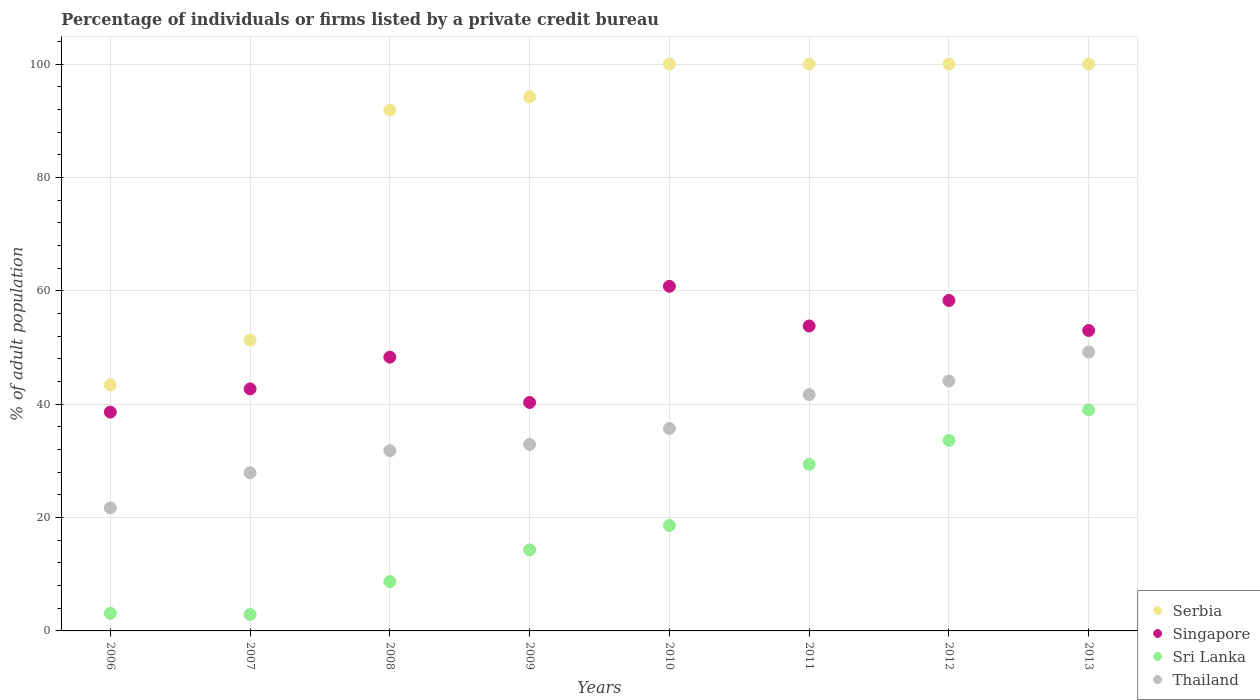Across all years, what is the maximum percentage of population listed by a private credit bureau in Singapore?
Offer a terse response. 60.8. Across all years, what is the minimum percentage of population listed by a private credit bureau in Thailand?
Provide a short and direct response. 21.7. In which year was the percentage of population listed by a private credit bureau in Sri Lanka minimum?
Provide a succinct answer. 2007. What is the total percentage of population listed by a private credit bureau in Singapore in the graph?
Keep it short and to the point. 395.8. What is the difference between the percentage of population listed by a private credit bureau in Singapore in 2007 and that in 2013?
Offer a very short reply. -10.3. What is the difference between the percentage of population listed by a private credit bureau in Thailand in 2011 and the percentage of population listed by a private credit bureau in Sri Lanka in 2013?
Make the answer very short. 2.7. What is the average percentage of population listed by a private credit bureau in Serbia per year?
Your answer should be very brief. 85.1. In the year 2009, what is the difference between the percentage of population listed by a private credit bureau in Serbia and percentage of population listed by a private credit bureau in Sri Lanka?
Offer a very short reply. 79.9. In how many years, is the percentage of population listed by a private credit bureau in Serbia greater than 76 %?
Give a very brief answer. 6. What is the ratio of the percentage of population listed by a private credit bureau in Thailand in 2006 to that in 2008?
Ensure brevity in your answer.  0.68. Is the difference between the percentage of population listed by a private credit bureau in Serbia in 2006 and 2008 greater than the difference between the percentage of population listed by a private credit bureau in Sri Lanka in 2006 and 2008?
Make the answer very short. No. What is the difference between the highest and the second highest percentage of population listed by a private credit bureau in Sri Lanka?
Provide a short and direct response. 5.4. What is the difference between the highest and the lowest percentage of population listed by a private credit bureau in Singapore?
Give a very brief answer. 22.2. In how many years, is the percentage of population listed by a private credit bureau in Serbia greater than the average percentage of population listed by a private credit bureau in Serbia taken over all years?
Offer a terse response. 6. Is the sum of the percentage of population listed by a private credit bureau in Singapore in 2012 and 2013 greater than the maximum percentage of population listed by a private credit bureau in Serbia across all years?
Make the answer very short. Yes. Is it the case that in every year, the sum of the percentage of population listed by a private credit bureau in Singapore and percentage of population listed by a private credit bureau in Sri Lanka  is greater than the sum of percentage of population listed by a private credit bureau in Thailand and percentage of population listed by a private credit bureau in Serbia?
Your answer should be very brief. Yes. Is it the case that in every year, the sum of the percentage of population listed by a private credit bureau in Singapore and percentage of population listed by a private credit bureau in Thailand  is greater than the percentage of population listed by a private credit bureau in Sri Lanka?
Give a very brief answer. Yes. Is the percentage of population listed by a private credit bureau in Singapore strictly greater than the percentage of population listed by a private credit bureau in Serbia over the years?
Your response must be concise. No. How many dotlines are there?
Give a very brief answer. 4. What is the difference between two consecutive major ticks on the Y-axis?
Offer a very short reply. 20. Does the graph contain any zero values?
Ensure brevity in your answer.  No. What is the title of the graph?
Offer a very short reply. Percentage of individuals or firms listed by a private credit bureau. Does "Puerto Rico" appear as one of the legend labels in the graph?
Offer a terse response. No. What is the label or title of the X-axis?
Give a very brief answer. Years. What is the label or title of the Y-axis?
Give a very brief answer. % of adult population. What is the % of adult population of Serbia in 2006?
Ensure brevity in your answer.  43.4. What is the % of adult population of Singapore in 2006?
Provide a short and direct response. 38.6. What is the % of adult population of Sri Lanka in 2006?
Make the answer very short. 3.1. What is the % of adult population of Thailand in 2006?
Ensure brevity in your answer.  21.7. What is the % of adult population of Serbia in 2007?
Your response must be concise. 51.3. What is the % of adult population of Singapore in 2007?
Offer a very short reply. 42.7. What is the % of adult population of Sri Lanka in 2007?
Keep it short and to the point. 2.9. What is the % of adult population in Thailand in 2007?
Your response must be concise. 27.9. What is the % of adult population of Serbia in 2008?
Your answer should be very brief. 91.9. What is the % of adult population in Singapore in 2008?
Your answer should be very brief. 48.3. What is the % of adult population of Sri Lanka in 2008?
Offer a terse response. 8.7. What is the % of adult population of Thailand in 2008?
Give a very brief answer. 31.8. What is the % of adult population in Serbia in 2009?
Ensure brevity in your answer.  94.2. What is the % of adult population of Singapore in 2009?
Give a very brief answer. 40.3. What is the % of adult population of Sri Lanka in 2009?
Provide a short and direct response. 14.3. What is the % of adult population of Thailand in 2009?
Keep it short and to the point. 32.9. What is the % of adult population of Singapore in 2010?
Your answer should be very brief. 60.8. What is the % of adult population of Thailand in 2010?
Give a very brief answer. 35.7. What is the % of adult population of Serbia in 2011?
Offer a terse response. 100. What is the % of adult population in Singapore in 2011?
Keep it short and to the point. 53.8. What is the % of adult population in Sri Lanka in 2011?
Provide a succinct answer. 29.4. What is the % of adult population of Thailand in 2011?
Give a very brief answer. 41.7. What is the % of adult population in Singapore in 2012?
Make the answer very short. 58.3. What is the % of adult population of Sri Lanka in 2012?
Your answer should be very brief. 33.6. What is the % of adult population in Thailand in 2012?
Offer a terse response. 44.1. What is the % of adult population in Singapore in 2013?
Keep it short and to the point. 53. What is the % of adult population of Thailand in 2013?
Ensure brevity in your answer.  49.2. Across all years, what is the maximum % of adult population in Serbia?
Your answer should be very brief. 100. Across all years, what is the maximum % of adult population of Singapore?
Provide a short and direct response. 60.8. Across all years, what is the maximum % of adult population in Thailand?
Make the answer very short. 49.2. Across all years, what is the minimum % of adult population in Serbia?
Your response must be concise. 43.4. Across all years, what is the minimum % of adult population of Singapore?
Give a very brief answer. 38.6. Across all years, what is the minimum % of adult population in Thailand?
Provide a succinct answer. 21.7. What is the total % of adult population in Serbia in the graph?
Your response must be concise. 680.8. What is the total % of adult population of Singapore in the graph?
Your response must be concise. 395.8. What is the total % of adult population in Sri Lanka in the graph?
Your response must be concise. 149.6. What is the total % of adult population of Thailand in the graph?
Make the answer very short. 285. What is the difference between the % of adult population of Thailand in 2006 and that in 2007?
Make the answer very short. -6.2. What is the difference between the % of adult population of Serbia in 2006 and that in 2008?
Keep it short and to the point. -48.5. What is the difference between the % of adult population of Serbia in 2006 and that in 2009?
Make the answer very short. -50.8. What is the difference between the % of adult population in Thailand in 2006 and that in 2009?
Offer a terse response. -11.2. What is the difference between the % of adult population of Serbia in 2006 and that in 2010?
Your answer should be compact. -56.6. What is the difference between the % of adult population in Singapore in 2006 and that in 2010?
Your response must be concise. -22.2. What is the difference between the % of adult population in Sri Lanka in 2006 and that in 2010?
Offer a terse response. -15.5. What is the difference between the % of adult population of Thailand in 2006 and that in 2010?
Your answer should be compact. -14. What is the difference between the % of adult population in Serbia in 2006 and that in 2011?
Make the answer very short. -56.6. What is the difference between the % of adult population in Singapore in 2006 and that in 2011?
Provide a short and direct response. -15.2. What is the difference between the % of adult population of Sri Lanka in 2006 and that in 2011?
Your answer should be compact. -26.3. What is the difference between the % of adult population of Thailand in 2006 and that in 2011?
Make the answer very short. -20. What is the difference between the % of adult population of Serbia in 2006 and that in 2012?
Your answer should be very brief. -56.6. What is the difference between the % of adult population of Singapore in 2006 and that in 2012?
Your response must be concise. -19.7. What is the difference between the % of adult population of Sri Lanka in 2006 and that in 2012?
Provide a succinct answer. -30.5. What is the difference between the % of adult population in Thailand in 2006 and that in 2012?
Give a very brief answer. -22.4. What is the difference between the % of adult population in Serbia in 2006 and that in 2013?
Offer a very short reply. -56.6. What is the difference between the % of adult population in Singapore in 2006 and that in 2013?
Make the answer very short. -14.4. What is the difference between the % of adult population in Sri Lanka in 2006 and that in 2013?
Provide a short and direct response. -35.9. What is the difference between the % of adult population in Thailand in 2006 and that in 2013?
Keep it short and to the point. -27.5. What is the difference between the % of adult population in Serbia in 2007 and that in 2008?
Give a very brief answer. -40.6. What is the difference between the % of adult population of Singapore in 2007 and that in 2008?
Provide a succinct answer. -5.6. What is the difference between the % of adult population in Sri Lanka in 2007 and that in 2008?
Give a very brief answer. -5.8. What is the difference between the % of adult population in Serbia in 2007 and that in 2009?
Make the answer very short. -42.9. What is the difference between the % of adult population in Sri Lanka in 2007 and that in 2009?
Give a very brief answer. -11.4. What is the difference between the % of adult population in Serbia in 2007 and that in 2010?
Your response must be concise. -48.7. What is the difference between the % of adult population in Singapore in 2007 and that in 2010?
Keep it short and to the point. -18.1. What is the difference between the % of adult population of Sri Lanka in 2007 and that in 2010?
Your answer should be compact. -15.7. What is the difference between the % of adult population of Serbia in 2007 and that in 2011?
Provide a short and direct response. -48.7. What is the difference between the % of adult population in Sri Lanka in 2007 and that in 2011?
Provide a succinct answer. -26.5. What is the difference between the % of adult population in Serbia in 2007 and that in 2012?
Offer a very short reply. -48.7. What is the difference between the % of adult population of Singapore in 2007 and that in 2012?
Your answer should be compact. -15.6. What is the difference between the % of adult population of Sri Lanka in 2007 and that in 2012?
Your response must be concise. -30.7. What is the difference between the % of adult population of Thailand in 2007 and that in 2012?
Keep it short and to the point. -16.2. What is the difference between the % of adult population of Serbia in 2007 and that in 2013?
Offer a terse response. -48.7. What is the difference between the % of adult population in Singapore in 2007 and that in 2013?
Ensure brevity in your answer.  -10.3. What is the difference between the % of adult population in Sri Lanka in 2007 and that in 2013?
Give a very brief answer. -36.1. What is the difference between the % of adult population in Thailand in 2007 and that in 2013?
Ensure brevity in your answer.  -21.3. What is the difference between the % of adult population in Singapore in 2008 and that in 2009?
Ensure brevity in your answer.  8. What is the difference between the % of adult population in Sri Lanka in 2008 and that in 2009?
Your answer should be compact. -5.6. What is the difference between the % of adult population in Sri Lanka in 2008 and that in 2010?
Provide a short and direct response. -9.9. What is the difference between the % of adult population in Serbia in 2008 and that in 2011?
Give a very brief answer. -8.1. What is the difference between the % of adult population in Singapore in 2008 and that in 2011?
Offer a very short reply. -5.5. What is the difference between the % of adult population in Sri Lanka in 2008 and that in 2011?
Your response must be concise. -20.7. What is the difference between the % of adult population of Serbia in 2008 and that in 2012?
Your answer should be compact. -8.1. What is the difference between the % of adult population of Sri Lanka in 2008 and that in 2012?
Offer a very short reply. -24.9. What is the difference between the % of adult population in Thailand in 2008 and that in 2012?
Your response must be concise. -12.3. What is the difference between the % of adult population of Sri Lanka in 2008 and that in 2013?
Provide a succinct answer. -30.3. What is the difference between the % of adult population of Thailand in 2008 and that in 2013?
Your answer should be compact. -17.4. What is the difference between the % of adult population of Serbia in 2009 and that in 2010?
Keep it short and to the point. -5.8. What is the difference between the % of adult population in Singapore in 2009 and that in 2010?
Ensure brevity in your answer.  -20.5. What is the difference between the % of adult population in Thailand in 2009 and that in 2010?
Your answer should be very brief. -2.8. What is the difference between the % of adult population of Sri Lanka in 2009 and that in 2011?
Your answer should be very brief. -15.1. What is the difference between the % of adult population of Serbia in 2009 and that in 2012?
Your response must be concise. -5.8. What is the difference between the % of adult population in Sri Lanka in 2009 and that in 2012?
Give a very brief answer. -19.3. What is the difference between the % of adult population in Serbia in 2009 and that in 2013?
Ensure brevity in your answer.  -5.8. What is the difference between the % of adult population in Sri Lanka in 2009 and that in 2013?
Ensure brevity in your answer.  -24.7. What is the difference between the % of adult population of Thailand in 2009 and that in 2013?
Ensure brevity in your answer.  -16.3. What is the difference between the % of adult population in Singapore in 2010 and that in 2011?
Your response must be concise. 7. What is the difference between the % of adult population of Serbia in 2010 and that in 2012?
Your answer should be very brief. 0. What is the difference between the % of adult population of Thailand in 2010 and that in 2012?
Your answer should be very brief. -8.4. What is the difference between the % of adult population in Singapore in 2010 and that in 2013?
Ensure brevity in your answer.  7.8. What is the difference between the % of adult population in Sri Lanka in 2010 and that in 2013?
Your answer should be compact. -20.4. What is the difference between the % of adult population in Thailand in 2010 and that in 2013?
Provide a short and direct response. -13.5. What is the difference between the % of adult population in Sri Lanka in 2011 and that in 2012?
Offer a very short reply. -4.2. What is the difference between the % of adult population of Sri Lanka in 2011 and that in 2013?
Ensure brevity in your answer.  -9.6. What is the difference between the % of adult population of Serbia in 2012 and that in 2013?
Your response must be concise. 0. What is the difference between the % of adult population of Singapore in 2012 and that in 2013?
Ensure brevity in your answer.  5.3. What is the difference between the % of adult population in Serbia in 2006 and the % of adult population in Singapore in 2007?
Ensure brevity in your answer.  0.7. What is the difference between the % of adult population in Serbia in 2006 and the % of adult population in Sri Lanka in 2007?
Ensure brevity in your answer.  40.5. What is the difference between the % of adult population in Serbia in 2006 and the % of adult population in Thailand in 2007?
Keep it short and to the point. 15.5. What is the difference between the % of adult population of Singapore in 2006 and the % of adult population of Sri Lanka in 2007?
Offer a terse response. 35.7. What is the difference between the % of adult population of Sri Lanka in 2006 and the % of adult population of Thailand in 2007?
Your answer should be very brief. -24.8. What is the difference between the % of adult population in Serbia in 2006 and the % of adult population in Singapore in 2008?
Provide a short and direct response. -4.9. What is the difference between the % of adult population of Serbia in 2006 and the % of adult population of Sri Lanka in 2008?
Keep it short and to the point. 34.7. What is the difference between the % of adult population in Singapore in 2006 and the % of adult population in Sri Lanka in 2008?
Ensure brevity in your answer.  29.9. What is the difference between the % of adult population of Sri Lanka in 2006 and the % of adult population of Thailand in 2008?
Provide a short and direct response. -28.7. What is the difference between the % of adult population in Serbia in 2006 and the % of adult population in Sri Lanka in 2009?
Your response must be concise. 29.1. What is the difference between the % of adult population in Serbia in 2006 and the % of adult population in Thailand in 2009?
Offer a very short reply. 10.5. What is the difference between the % of adult population of Singapore in 2006 and the % of adult population of Sri Lanka in 2009?
Give a very brief answer. 24.3. What is the difference between the % of adult population in Singapore in 2006 and the % of adult population in Thailand in 2009?
Your response must be concise. 5.7. What is the difference between the % of adult population of Sri Lanka in 2006 and the % of adult population of Thailand in 2009?
Your answer should be very brief. -29.8. What is the difference between the % of adult population in Serbia in 2006 and the % of adult population in Singapore in 2010?
Offer a terse response. -17.4. What is the difference between the % of adult population in Serbia in 2006 and the % of adult population in Sri Lanka in 2010?
Your response must be concise. 24.8. What is the difference between the % of adult population of Singapore in 2006 and the % of adult population of Thailand in 2010?
Give a very brief answer. 2.9. What is the difference between the % of adult population of Sri Lanka in 2006 and the % of adult population of Thailand in 2010?
Make the answer very short. -32.6. What is the difference between the % of adult population in Serbia in 2006 and the % of adult population in Sri Lanka in 2011?
Make the answer very short. 14. What is the difference between the % of adult population of Sri Lanka in 2006 and the % of adult population of Thailand in 2011?
Make the answer very short. -38.6. What is the difference between the % of adult population in Serbia in 2006 and the % of adult population in Singapore in 2012?
Provide a succinct answer. -14.9. What is the difference between the % of adult population in Serbia in 2006 and the % of adult population in Thailand in 2012?
Your response must be concise. -0.7. What is the difference between the % of adult population of Sri Lanka in 2006 and the % of adult population of Thailand in 2012?
Keep it short and to the point. -41. What is the difference between the % of adult population in Serbia in 2006 and the % of adult population in Singapore in 2013?
Your response must be concise. -9.6. What is the difference between the % of adult population of Serbia in 2006 and the % of adult population of Sri Lanka in 2013?
Offer a very short reply. 4.4. What is the difference between the % of adult population of Singapore in 2006 and the % of adult population of Sri Lanka in 2013?
Your response must be concise. -0.4. What is the difference between the % of adult population in Singapore in 2006 and the % of adult population in Thailand in 2013?
Ensure brevity in your answer.  -10.6. What is the difference between the % of adult population in Sri Lanka in 2006 and the % of adult population in Thailand in 2013?
Your answer should be very brief. -46.1. What is the difference between the % of adult population of Serbia in 2007 and the % of adult population of Singapore in 2008?
Offer a very short reply. 3. What is the difference between the % of adult population in Serbia in 2007 and the % of adult population in Sri Lanka in 2008?
Offer a very short reply. 42.6. What is the difference between the % of adult population of Serbia in 2007 and the % of adult population of Thailand in 2008?
Keep it short and to the point. 19.5. What is the difference between the % of adult population in Sri Lanka in 2007 and the % of adult population in Thailand in 2008?
Your answer should be compact. -28.9. What is the difference between the % of adult population of Singapore in 2007 and the % of adult population of Sri Lanka in 2009?
Your answer should be very brief. 28.4. What is the difference between the % of adult population of Serbia in 2007 and the % of adult population of Sri Lanka in 2010?
Your answer should be very brief. 32.7. What is the difference between the % of adult population of Serbia in 2007 and the % of adult population of Thailand in 2010?
Offer a very short reply. 15.6. What is the difference between the % of adult population of Singapore in 2007 and the % of adult population of Sri Lanka in 2010?
Your response must be concise. 24.1. What is the difference between the % of adult population in Singapore in 2007 and the % of adult population in Thailand in 2010?
Keep it short and to the point. 7. What is the difference between the % of adult population in Sri Lanka in 2007 and the % of adult population in Thailand in 2010?
Your answer should be compact. -32.8. What is the difference between the % of adult population of Serbia in 2007 and the % of adult population of Sri Lanka in 2011?
Your answer should be very brief. 21.9. What is the difference between the % of adult population of Serbia in 2007 and the % of adult population of Thailand in 2011?
Your response must be concise. 9.6. What is the difference between the % of adult population of Singapore in 2007 and the % of adult population of Thailand in 2011?
Your answer should be very brief. 1. What is the difference between the % of adult population of Sri Lanka in 2007 and the % of adult population of Thailand in 2011?
Offer a very short reply. -38.8. What is the difference between the % of adult population of Sri Lanka in 2007 and the % of adult population of Thailand in 2012?
Give a very brief answer. -41.2. What is the difference between the % of adult population of Serbia in 2007 and the % of adult population of Thailand in 2013?
Keep it short and to the point. 2.1. What is the difference between the % of adult population of Sri Lanka in 2007 and the % of adult population of Thailand in 2013?
Provide a succinct answer. -46.3. What is the difference between the % of adult population of Serbia in 2008 and the % of adult population of Singapore in 2009?
Your response must be concise. 51.6. What is the difference between the % of adult population of Serbia in 2008 and the % of adult population of Sri Lanka in 2009?
Make the answer very short. 77.6. What is the difference between the % of adult population of Singapore in 2008 and the % of adult population of Sri Lanka in 2009?
Give a very brief answer. 34. What is the difference between the % of adult population of Sri Lanka in 2008 and the % of adult population of Thailand in 2009?
Keep it short and to the point. -24.2. What is the difference between the % of adult population in Serbia in 2008 and the % of adult population in Singapore in 2010?
Keep it short and to the point. 31.1. What is the difference between the % of adult population in Serbia in 2008 and the % of adult population in Sri Lanka in 2010?
Offer a very short reply. 73.3. What is the difference between the % of adult population in Serbia in 2008 and the % of adult population in Thailand in 2010?
Offer a terse response. 56.2. What is the difference between the % of adult population in Singapore in 2008 and the % of adult population in Sri Lanka in 2010?
Make the answer very short. 29.7. What is the difference between the % of adult population of Sri Lanka in 2008 and the % of adult population of Thailand in 2010?
Ensure brevity in your answer.  -27. What is the difference between the % of adult population in Serbia in 2008 and the % of adult population in Singapore in 2011?
Make the answer very short. 38.1. What is the difference between the % of adult population of Serbia in 2008 and the % of adult population of Sri Lanka in 2011?
Offer a terse response. 62.5. What is the difference between the % of adult population in Serbia in 2008 and the % of adult population in Thailand in 2011?
Your response must be concise. 50.2. What is the difference between the % of adult population of Singapore in 2008 and the % of adult population of Thailand in 2011?
Keep it short and to the point. 6.6. What is the difference between the % of adult population of Sri Lanka in 2008 and the % of adult population of Thailand in 2011?
Your answer should be compact. -33. What is the difference between the % of adult population in Serbia in 2008 and the % of adult population in Singapore in 2012?
Your answer should be very brief. 33.6. What is the difference between the % of adult population in Serbia in 2008 and the % of adult population in Sri Lanka in 2012?
Make the answer very short. 58.3. What is the difference between the % of adult population in Serbia in 2008 and the % of adult population in Thailand in 2012?
Your answer should be very brief. 47.8. What is the difference between the % of adult population in Singapore in 2008 and the % of adult population in Sri Lanka in 2012?
Provide a short and direct response. 14.7. What is the difference between the % of adult population of Singapore in 2008 and the % of adult population of Thailand in 2012?
Your response must be concise. 4.2. What is the difference between the % of adult population in Sri Lanka in 2008 and the % of adult population in Thailand in 2012?
Your response must be concise. -35.4. What is the difference between the % of adult population in Serbia in 2008 and the % of adult population in Singapore in 2013?
Provide a short and direct response. 38.9. What is the difference between the % of adult population in Serbia in 2008 and the % of adult population in Sri Lanka in 2013?
Provide a short and direct response. 52.9. What is the difference between the % of adult population in Serbia in 2008 and the % of adult population in Thailand in 2013?
Make the answer very short. 42.7. What is the difference between the % of adult population in Singapore in 2008 and the % of adult population in Thailand in 2013?
Provide a succinct answer. -0.9. What is the difference between the % of adult population in Sri Lanka in 2008 and the % of adult population in Thailand in 2013?
Your answer should be compact. -40.5. What is the difference between the % of adult population of Serbia in 2009 and the % of adult population of Singapore in 2010?
Make the answer very short. 33.4. What is the difference between the % of adult population in Serbia in 2009 and the % of adult population in Sri Lanka in 2010?
Offer a very short reply. 75.6. What is the difference between the % of adult population of Serbia in 2009 and the % of adult population of Thailand in 2010?
Provide a succinct answer. 58.5. What is the difference between the % of adult population of Singapore in 2009 and the % of adult population of Sri Lanka in 2010?
Offer a very short reply. 21.7. What is the difference between the % of adult population of Singapore in 2009 and the % of adult population of Thailand in 2010?
Offer a very short reply. 4.6. What is the difference between the % of adult population of Sri Lanka in 2009 and the % of adult population of Thailand in 2010?
Offer a very short reply. -21.4. What is the difference between the % of adult population of Serbia in 2009 and the % of adult population of Singapore in 2011?
Make the answer very short. 40.4. What is the difference between the % of adult population of Serbia in 2009 and the % of adult population of Sri Lanka in 2011?
Make the answer very short. 64.8. What is the difference between the % of adult population in Serbia in 2009 and the % of adult population in Thailand in 2011?
Make the answer very short. 52.5. What is the difference between the % of adult population in Singapore in 2009 and the % of adult population in Sri Lanka in 2011?
Your answer should be compact. 10.9. What is the difference between the % of adult population in Singapore in 2009 and the % of adult population in Thailand in 2011?
Your response must be concise. -1.4. What is the difference between the % of adult population in Sri Lanka in 2009 and the % of adult population in Thailand in 2011?
Offer a very short reply. -27.4. What is the difference between the % of adult population in Serbia in 2009 and the % of adult population in Singapore in 2012?
Provide a succinct answer. 35.9. What is the difference between the % of adult population in Serbia in 2009 and the % of adult population in Sri Lanka in 2012?
Ensure brevity in your answer.  60.6. What is the difference between the % of adult population in Serbia in 2009 and the % of adult population in Thailand in 2012?
Provide a succinct answer. 50.1. What is the difference between the % of adult population of Singapore in 2009 and the % of adult population of Sri Lanka in 2012?
Offer a terse response. 6.7. What is the difference between the % of adult population of Sri Lanka in 2009 and the % of adult population of Thailand in 2012?
Offer a very short reply. -29.8. What is the difference between the % of adult population in Serbia in 2009 and the % of adult population in Singapore in 2013?
Make the answer very short. 41.2. What is the difference between the % of adult population of Serbia in 2009 and the % of adult population of Sri Lanka in 2013?
Offer a very short reply. 55.2. What is the difference between the % of adult population of Sri Lanka in 2009 and the % of adult population of Thailand in 2013?
Your response must be concise. -34.9. What is the difference between the % of adult population of Serbia in 2010 and the % of adult population of Singapore in 2011?
Offer a very short reply. 46.2. What is the difference between the % of adult population of Serbia in 2010 and the % of adult population of Sri Lanka in 2011?
Provide a short and direct response. 70.6. What is the difference between the % of adult population in Serbia in 2010 and the % of adult population in Thailand in 2011?
Provide a succinct answer. 58.3. What is the difference between the % of adult population of Singapore in 2010 and the % of adult population of Sri Lanka in 2011?
Ensure brevity in your answer.  31.4. What is the difference between the % of adult population of Singapore in 2010 and the % of adult population of Thailand in 2011?
Keep it short and to the point. 19.1. What is the difference between the % of adult population in Sri Lanka in 2010 and the % of adult population in Thailand in 2011?
Your answer should be very brief. -23.1. What is the difference between the % of adult population in Serbia in 2010 and the % of adult population in Singapore in 2012?
Keep it short and to the point. 41.7. What is the difference between the % of adult population in Serbia in 2010 and the % of adult population in Sri Lanka in 2012?
Provide a succinct answer. 66.4. What is the difference between the % of adult population of Serbia in 2010 and the % of adult population of Thailand in 2012?
Provide a short and direct response. 55.9. What is the difference between the % of adult population in Singapore in 2010 and the % of adult population in Sri Lanka in 2012?
Offer a terse response. 27.2. What is the difference between the % of adult population in Singapore in 2010 and the % of adult population in Thailand in 2012?
Your response must be concise. 16.7. What is the difference between the % of adult population in Sri Lanka in 2010 and the % of adult population in Thailand in 2012?
Keep it short and to the point. -25.5. What is the difference between the % of adult population of Serbia in 2010 and the % of adult population of Singapore in 2013?
Provide a short and direct response. 47. What is the difference between the % of adult population of Serbia in 2010 and the % of adult population of Thailand in 2013?
Your response must be concise. 50.8. What is the difference between the % of adult population of Singapore in 2010 and the % of adult population of Sri Lanka in 2013?
Offer a very short reply. 21.8. What is the difference between the % of adult population of Singapore in 2010 and the % of adult population of Thailand in 2013?
Offer a very short reply. 11.6. What is the difference between the % of adult population of Sri Lanka in 2010 and the % of adult population of Thailand in 2013?
Keep it short and to the point. -30.6. What is the difference between the % of adult population of Serbia in 2011 and the % of adult population of Singapore in 2012?
Ensure brevity in your answer.  41.7. What is the difference between the % of adult population of Serbia in 2011 and the % of adult population of Sri Lanka in 2012?
Offer a very short reply. 66.4. What is the difference between the % of adult population of Serbia in 2011 and the % of adult population of Thailand in 2012?
Ensure brevity in your answer.  55.9. What is the difference between the % of adult population of Singapore in 2011 and the % of adult population of Sri Lanka in 2012?
Your answer should be compact. 20.2. What is the difference between the % of adult population of Singapore in 2011 and the % of adult population of Thailand in 2012?
Provide a succinct answer. 9.7. What is the difference between the % of adult population in Sri Lanka in 2011 and the % of adult population in Thailand in 2012?
Your answer should be very brief. -14.7. What is the difference between the % of adult population of Serbia in 2011 and the % of adult population of Singapore in 2013?
Keep it short and to the point. 47. What is the difference between the % of adult population in Serbia in 2011 and the % of adult population in Thailand in 2013?
Offer a very short reply. 50.8. What is the difference between the % of adult population of Singapore in 2011 and the % of adult population of Sri Lanka in 2013?
Offer a terse response. 14.8. What is the difference between the % of adult population of Sri Lanka in 2011 and the % of adult population of Thailand in 2013?
Provide a short and direct response. -19.8. What is the difference between the % of adult population in Serbia in 2012 and the % of adult population in Sri Lanka in 2013?
Keep it short and to the point. 61. What is the difference between the % of adult population of Serbia in 2012 and the % of adult population of Thailand in 2013?
Offer a very short reply. 50.8. What is the difference between the % of adult population in Singapore in 2012 and the % of adult population in Sri Lanka in 2013?
Your answer should be very brief. 19.3. What is the difference between the % of adult population in Singapore in 2012 and the % of adult population in Thailand in 2013?
Your answer should be very brief. 9.1. What is the difference between the % of adult population of Sri Lanka in 2012 and the % of adult population of Thailand in 2013?
Provide a succinct answer. -15.6. What is the average % of adult population of Serbia per year?
Give a very brief answer. 85.1. What is the average % of adult population of Singapore per year?
Provide a succinct answer. 49.48. What is the average % of adult population in Thailand per year?
Your answer should be very brief. 35.62. In the year 2006, what is the difference between the % of adult population in Serbia and % of adult population in Singapore?
Provide a short and direct response. 4.8. In the year 2006, what is the difference between the % of adult population in Serbia and % of adult population in Sri Lanka?
Your answer should be very brief. 40.3. In the year 2006, what is the difference between the % of adult population in Serbia and % of adult population in Thailand?
Ensure brevity in your answer.  21.7. In the year 2006, what is the difference between the % of adult population in Singapore and % of adult population in Sri Lanka?
Offer a very short reply. 35.5. In the year 2006, what is the difference between the % of adult population in Sri Lanka and % of adult population in Thailand?
Your response must be concise. -18.6. In the year 2007, what is the difference between the % of adult population in Serbia and % of adult population in Singapore?
Your answer should be very brief. 8.6. In the year 2007, what is the difference between the % of adult population of Serbia and % of adult population of Sri Lanka?
Your answer should be very brief. 48.4. In the year 2007, what is the difference between the % of adult population in Serbia and % of adult population in Thailand?
Keep it short and to the point. 23.4. In the year 2007, what is the difference between the % of adult population of Singapore and % of adult population of Sri Lanka?
Your response must be concise. 39.8. In the year 2007, what is the difference between the % of adult population in Singapore and % of adult population in Thailand?
Give a very brief answer. 14.8. In the year 2007, what is the difference between the % of adult population in Sri Lanka and % of adult population in Thailand?
Make the answer very short. -25. In the year 2008, what is the difference between the % of adult population of Serbia and % of adult population of Singapore?
Offer a very short reply. 43.6. In the year 2008, what is the difference between the % of adult population in Serbia and % of adult population in Sri Lanka?
Keep it short and to the point. 83.2. In the year 2008, what is the difference between the % of adult population of Serbia and % of adult population of Thailand?
Your response must be concise. 60.1. In the year 2008, what is the difference between the % of adult population of Singapore and % of adult population of Sri Lanka?
Your answer should be compact. 39.6. In the year 2008, what is the difference between the % of adult population in Singapore and % of adult population in Thailand?
Provide a short and direct response. 16.5. In the year 2008, what is the difference between the % of adult population in Sri Lanka and % of adult population in Thailand?
Offer a terse response. -23.1. In the year 2009, what is the difference between the % of adult population of Serbia and % of adult population of Singapore?
Provide a succinct answer. 53.9. In the year 2009, what is the difference between the % of adult population in Serbia and % of adult population in Sri Lanka?
Your answer should be compact. 79.9. In the year 2009, what is the difference between the % of adult population of Serbia and % of adult population of Thailand?
Provide a succinct answer. 61.3. In the year 2009, what is the difference between the % of adult population of Singapore and % of adult population of Sri Lanka?
Ensure brevity in your answer.  26. In the year 2009, what is the difference between the % of adult population in Sri Lanka and % of adult population in Thailand?
Offer a very short reply. -18.6. In the year 2010, what is the difference between the % of adult population of Serbia and % of adult population of Singapore?
Your answer should be compact. 39.2. In the year 2010, what is the difference between the % of adult population of Serbia and % of adult population of Sri Lanka?
Provide a short and direct response. 81.4. In the year 2010, what is the difference between the % of adult population in Serbia and % of adult population in Thailand?
Offer a terse response. 64.3. In the year 2010, what is the difference between the % of adult population in Singapore and % of adult population in Sri Lanka?
Ensure brevity in your answer.  42.2. In the year 2010, what is the difference between the % of adult population in Singapore and % of adult population in Thailand?
Ensure brevity in your answer.  25.1. In the year 2010, what is the difference between the % of adult population in Sri Lanka and % of adult population in Thailand?
Offer a very short reply. -17.1. In the year 2011, what is the difference between the % of adult population of Serbia and % of adult population of Singapore?
Give a very brief answer. 46.2. In the year 2011, what is the difference between the % of adult population in Serbia and % of adult population in Sri Lanka?
Your answer should be very brief. 70.6. In the year 2011, what is the difference between the % of adult population in Serbia and % of adult population in Thailand?
Give a very brief answer. 58.3. In the year 2011, what is the difference between the % of adult population in Singapore and % of adult population in Sri Lanka?
Provide a succinct answer. 24.4. In the year 2012, what is the difference between the % of adult population of Serbia and % of adult population of Singapore?
Give a very brief answer. 41.7. In the year 2012, what is the difference between the % of adult population in Serbia and % of adult population in Sri Lanka?
Provide a short and direct response. 66.4. In the year 2012, what is the difference between the % of adult population in Serbia and % of adult population in Thailand?
Offer a very short reply. 55.9. In the year 2012, what is the difference between the % of adult population in Singapore and % of adult population in Sri Lanka?
Your answer should be compact. 24.7. In the year 2012, what is the difference between the % of adult population of Singapore and % of adult population of Thailand?
Your answer should be compact. 14.2. In the year 2012, what is the difference between the % of adult population of Sri Lanka and % of adult population of Thailand?
Ensure brevity in your answer.  -10.5. In the year 2013, what is the difference between the % of adult population of Serbia and % of adult population of Singapore?
Keep it short and to the point. 47. In the year 2013, what is the difference between the % of adult population in Serbia and % of adult population in Sri Lanka?
Your answer should be very brief. 61. In the year 2013, what is the difference between the % of adult population in Serbia and % of adult population in Thailand?
Make the answer very short. 50.8. In the year 2013, what is the difference between the % of adult population in Singapore and % of adult population in Thailand?
Provide a succinct answer. 3.8. In the year 2013, what is the difference between the % of adult population of Sri Lanka and % of adult population of Thailand?
Your answer should be compact. -10.2. What is the ratio of the % of adult population in Serbia in 2006 to that in 2007?
Offer a terse response. 0.85. What is the ratio of the % of adult population in Singapore in 2006 to that in 2007?
Provide a short and direct response. 0.9. What is the ratio of the % of adult population in Sri Lanka in 2006 to that in 2007?
Offer a terse response. 1.07. What is the ratio of the % of adult population of Thailand in 2006 to that in 2007?
Offer a terse response. 0.78. What is the ratio of the % of adult population in Serbia in 2006 to that in 2008?
Your response must be concise. 0.47. What is the ratio of the % of adult population of Singapore in 2006 to that in 2008?
Make the answer very short. 0.8. What is the ratio of the % of adult population of Sri Lanka in 2006 to that in 2008?
Your answer should be compact. 0.36. What is the ratio of the % of adult population of Thailand in 2006 to that in 2008?
Your answer should be very brief. 0.68. What is the ratio of the % of adult population in Serbia in 2006 to that in 2009?
Make the answer very short. 0.46. What is the ratio of the % of adult population in Singapore in 2006 to that in 2009?
Ensure brevity in your answer.  0.96. What is the ratio of the % of adult population in Sri Lanka in 2006 to that in 2009?
Give a very brief answer. 0.22. What is the ratio of the % of adult population in Thailand in 2006 to that in 2009?
Ensure brevity in your answer.  0.66. What is the ratio of the % of adult population of Serbia in 2006 to that in 2010?
Provide a short and direct response. 0.43. What is the ratio of the % of adult population in Singapore in 2006 to that in 2010?
Make the answer very short. 0.63. What is the ratio of the % of adult population of Thailand in 2006 to that in 2010?
Give a very brief answer. 0.61. What is the ratio of the % of adult population in Serbia in 2006 to that in 2011?
Your response must be concise. 0.43. What is the ratio of the % of adult population of Singapore in 2006 to that in 2011?
Give a very brief answer. 0.72. What is the ratio of the % of adult population in Sri Lanka in 2006 to that in 2011?
Offer a terse response. 0.11. What is the ratio of the % of adult population of Thailand in 2006 to that in 2011?
Ensure brevity in your answer.  0.52. What is the ratio of the % of adult population in Serbia in 2006 to that in 2012?
Your answer should be compact. 0.43. What is the ratio of the % of adult population in Singapore in 2006 to that in 2012?
Make the answer very short. 0.66. What is the ratio of the % of adult population in Sri Lanka in 2006 to that in 2012?
Make the answer very short. 0.09. What is the ratio of the % of adult population in Thailand in 2006 to that in 2012?
Give a very brief answer. 0.49. What is the ratio of the % of adult population in Serbia in 2006 to that in 2013?
Keep it short and to the point. 0.43. What is the ratio of the % of adult population of Singapore in 2006 to that in 2013?
Offer a terse response. 0.73. What is the ratio of the % of adult population in Sri Lanka in 2006 to that in 2013?
Provide a succinct answer. 0.08. What is the ratio of the % of adult population of Thailand in 2006 to that in 2013?
Your response must be concise. 0.44. What is the ratio of the % of adult population of Serbia in 2007 to that in 2008?
Your answer should be compact. 0.56. What is the ratio of the % of adult population in Singapore in 2007 to that in 2008?
Offer a very short reply. 0.88. What is the ratio of the % of adult population in Thailand in 2007 to that in 2008?
Offer a very short reply. 0.88. What is the ratio of the % of adult population of Serbia in 2007 to that in 2009?
Provide a succinct answer. 0.54. What is the ratio of the % of adult population of Singapore in 2007 to that in 2009?
Ensure brevity in your answer.  1.06. What is the ratio of the % of adult population in Sri Lanka in 2007 to that in 2009?
Give a very brief answer. 0.2. What is the ratio of the % of adult population of Thailand in 2007 to that in 2009?
Offer a very short reply. 0.85. What is the ratio of the % of adult population of Serbia in 2007 to that in 2010?
Keep it short and to the point. 0.51. What is the ratio of the % of adult population of Singapore in 2007 to that in 2010?
Ensure brevity in your answer.  0.7. What is the ratio of the % of adult population of Sri Lanka in 2007 to that in 2010?
Your answer should be very brief. 0.16. What is the ratio of the % of adult population of Thailand in 2007 to that in 2010?
Your response must be concise. 0.78. What is the ratio of the % of adult population in Serbia in 2007 to that in 2011?
Give a very brief answer. 0.51. What is the ratio of the % of adult population in Singapore in 2007 to that in 2011?
Provide a short and direct response. 0.79. What is the ratio of the % of adult population in Sri Lanka in 2007 to that in 2011?
Provide a succinct answer. 0.1. What is the ratio of the % of adult population of Thailand in 2007 to that in 2011?
Your answer should be compact. 0.67. What is the ratio of the % of adult population of Serbia in 2007 to that in 2012?
Your answer should be very brief. 0.51. What is the ratio of the % of adult population in Singapore in 2007 to that in 2012?
Your answer should be very brief. 0.73. What is the ratio of the % of adult population in Sri Lanka in 2007 to that in 2012?
Ensure brevity in your answer.  0.09. What is the ratio of the % of adult population in Thailand in 2007 to that in 2012?
Your answer should be compact. 0.63. What is the ratio of the % of adult population of Serbia in 2007 to that in 2013?
Ensure brevity in your answer.  0.51. What is the ratio of the % of adult population in Singapore in 2007 to that in 2013?
Make the answer very short. 0.81. What is the ratio of the % of adult population of Sri Lanka in 2007 to that in 2013?
Offer a very short reply. 0.07. What is the ratio of the % of adult population of Thailand in 2007 to that in 2013?
Your answer should be compact. 0.57. What is the ratio of the % of adult population of Serbia in 2008 to that in 2009?
Make the answer very short. 0.98. What is the ratio of the % of adult population of Singapore in 2008 to that in 2009?
Your answer should be compact. 1.2. What is the ratio of the % of adult population in Sri Lanka in 2008 to that in 2009?
Provide a short and direct response. 0.61. What is the ratio of the % of adult population in Thailand in 2008 to that in 2009?
Ensure brevity in your answer.  0.97. What is the ratio of the % of adult population in Serbia in 2008 to that in 2010?
Your answer should be compact. 0.92. What is the ratio of the % of adult population of Singapore in 2008 to that in 2010?
Keep it short and to the point. 0.79. What is the ratio of the % of adult population of Sri Lanka in 2008 to that in 2010?
Ensure brevity in your answer.  0.47. What is the ratio of the % of adult population in Thailand in 2008 to that in 2010?
Ensure brevity in your answer.  0.89. What is the ratio of the % of adult population of Serbia in 2008 to that in 2011?
Offer a terse response. 0.92. What is the ratio of the % of adult population of Singapore in 2008 to that in 2011?
Give a very brief answer. 0.9. What is the ratio of the % of adult population of Sri Lanka in 2008 to that in 2011?
Your answer should be very brief. 0.3. What is the ratio of the % of adult population of Thailand in 2008 to that in 2011?
Your response must be concise. 0.76. What is the ratio of the % of adult population in Serbia in 2008 to that in 2012?
Your answer should be compact. 0.92. What is the ratio of the % of adult population in Singapore in 2008 to that in 2012?
Your answer should be compact. 0.83. What is the ratio of the % of adult population of Sri Lanka in 2008 to that in 2012?
Provide a short and direct response. 0.26. What is the ratio of the % of adult population in Thailand in 2008 to that in 2012?
Provide a short and direct response. 0.72. What is the ratio of the % of adult population of Serbia in 2008 to that in 2013?
Your response must be concise. 0.92. What is the ratio of the % of adult population of Singapore in 2008 to that in 2013?
Give a very brief answer. 0.91. What is the ratio of the % of adult population in Sri Lanka in 2008 to that in 2013?
Provide a short and direct response. 0.22. What is the ratio of the % of adult population in Thailand in 2008 to that in 2013?
Offer a very short reply. 0.65. What is the ratio of the % of adult population in Serbia in 2009 to that in 2010?
Offer a terse response. 0.94. What is the ratio of the % of adult population in Singapore in 2009 to that in 2010?
Ensure brevity in your answer.  0.66. What is the ratio of the % of adult population of Sri Lanka in 2009 to that in 2010?
Your answer should be compact. 0.77. What is the ratio of the % of adult population of Thailand in 2009 to that in 2010?
Give a very brief answer. 0.92. What is the ratio of the % of adult population in Serbia in 2009 to that in 2011?
Your response must be concise. 0.94. What is the ratio of the % of adult population of Singapore in 2009 to that in 2011?
Provide a succinct answer. 0.75. What is the ratio of the % of adult population of Sri Lanka in 2009 to that in 2011?
Provide a short and direct response. 0.49. What is the ratio of the % of adult population of Thailand in 2009 to that in 2011?
Your response must be concise. 0.79. What is the ratio of the % of adult population in Serbia in 2009 to that in 2012?
Offer a very short reply. 0.94. What is the ratio of the % of adult population of Singapore in 2009 to that in 2012?
Ensure brevity in your answer.  0.69. What is the ratio of the % of adult population of Sri Lanka in 2009 to that in 2012?
Your answer should be compact. 0.43. What is the ratio of the % of adult population of Thailand in 2009 to that in 2012?
Give a very brief answer. 0.75. What is the ratio of the % of adult population in Serbia in 2009 to that in 2013?
Offer a terse response. 0.94. What is the ratio of the % of adult population of Singapore in 2009 to that in 2013?
Your response must be concise. 0.76. What is the ratio of the % of adult population in Sri Lanka in 2009 to that in 2013?
Make the answer very short. 0.37. What is the ratio of the % of adult population of Thailand in 2009 to that in 2013?
Give a very brief answer. 0.67. What is the ratio of the % of adult population in Singapore in 2010 to that in 2011?
Your response must be concise. 1.13. What is the ratio of the % of adult population in Sri Lanka in 2010 to that in 2011?
Offer a very short reply. 0.63. What is the ratio of the % of adult population of Thailand in 2010 to that in 2011?
Make the answer very short. 0.86. What is the ratio of the % of adult population of Singapore in 2010 to that in 2012?
Give a very brief answer. 1.04. What is the ratio of the % of adult population of Sri Lanka in 2010 to that in 2012?
Your answer should be very brief. 0.55. What is the ratio of the % of adult population of Thailand in 2010 to that in 2012?
Keep it short and to the point. 0.81. What is the ratio of the % of adult population of Singapore in 2010 to that in 2013?
Offer a terse response. 1.15. What is the ratio of the % of adult population of Sri Lanka in 2010 to that in 2013?
Your response must be concise. 0.48. What is the ratio of the % of adult population of Thailand in 2010 to that in 2013?
Your answer should be very brief. 0.73. What is the ratio of the % of adult population in Serbia in 2011 to that in 2012?
Provide a short and direct response. 1. What is the ratio of the % of adult population in Singapore in 2011 to that in 2012?
Your answer should be compact. 0.92. What is the ratio of the % of adult population in Thailand in 2011 to that in 2012?
Offer a terse response. 0.95. What is the ratio of the % of adult population in Serbia in 2011 to that in 2013?
Make the answer very short. 1. What is the ratio of the % of adult population in Singapore in 2011 to that in 2013?
Provide a short and direct response. 1.02. What is the ratio of the % of adult population in Sri Lanka in 2011 to that in 2013?
Your response must be concise. 0.75. What is the ratio of the % of adult population of Thailand in 2011 to that in 2013?
Keep it short and to the point. 0.85. What is the ratio of the % of adult population of Serbia in 2012 to that in 2013?
Provide a short and direct response. 1. What is the ratio of the % of adult population of Sri Lanka in 2012 to that in 2013?
Ensure brevity in your answer.  0.86. What is the ratio of the % of adult population of Thailand in 2012 to that in 2013?
Offer a terse response. 0.9. What is the difference between the highest and the second highest % of adult population of Singapore?
Offer a terse response. 2.5. What is the difference between the highest and the second highest % of adult population of Thailand?
Provide a succinct answer. 5.1. What is the difference between the highest and the lowest % of adult population of Serbia?
Ensure brevity in your answer.  56.6. What is the difference between the highest and the lowest % of adult population in Singapore?
Provide a short and direct response. 22.2. What is the difference between the highest and the lowest % of adult population in Sri Lanka?
Give a very brief answer. 36.1. 